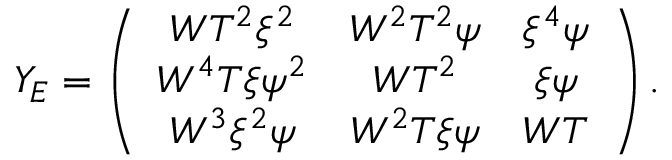Convert formula to latex. <formula><loc_0><loc_0><loc_500><loc_500>Y _ { E } = \left ( \begin{array} { c c c } { { W T ^ { 2 } \xi ^ { 2 } } } & { { W ^ { 2 } T ^ { 2 } \psi } } & { { \xi ^ { 4 } \psi } } \\ { { W ^ { 4 } T \xi \psi ^ { 2 } } } & { { W T ^ { 2 } } } & { \xi \psi } \\ { { W ^ { 3 } \xi ^ { 2 } \psi } } & { { W ^ { 2 } T \xi \psi } } & { W T } \end{array} \right ) .</formula> 